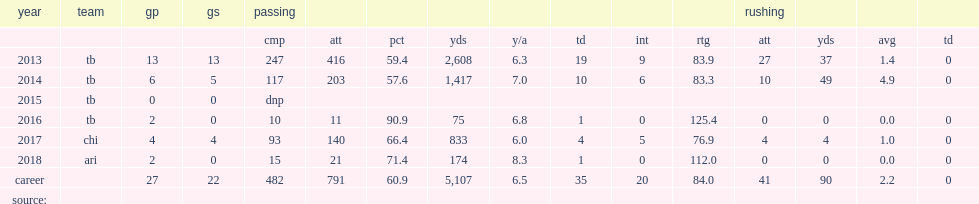In four games, how many passing yards did mike glennon finish with? 833.0. In four games, how many touchdowns did mike glennon finish with? 4.0. In four games, how many interceptions did mike glennon finish with? 5.0. Would you mind parsing the complete table? {'header': ['year', 'team', 'gp', 'gs', 'passing', '', '', '', '', '', '', '', 'rushing', '', '', ''], 'rows': [['', '', '', '', 'cmp', 'att', 'pct', 'yds', 'y/a', 'td', 'int', 'rtg', 'att', 'yds', 'avg', 'td'], ['2013', 'tb', '13', '13', '247', '416', '59.4', '2,608', '6.3', '19', '9', '83.9', '27', '37', '1.4', '0'], ['2014', 'tb', '6', '5', '117', '203', '57.6', '1,417', '7.0', '10', '6', '83.3', '10', '49', '4.9', '0'], ['2015', 'tb', '0', '0', 'dnp', '', '', '', '', '', '', '', '', '', '', ''], ['2016', 'tb', '2', '0', '10', '11', '90.9', '75', '6.8', '1', '0', '125.4', '0', '0', '0.0', '0'], ['2017', 'chi', '4', '4', '93', '140', '66.4', '833', '6.0', '4', '5', '76.9', '4', '4', '1.0', '0'], ['2018', 'ari', '2', '0', '15', '21', '71.4', '174', '8.3', '1', '0', '112.0', '0', '0', '0.0', '0'], ['career', '', '27', '22', '482', '791', '60.9', '5,107', '6.5', '35', '20', '84.0', '41', '90', '2.2', '0'], ['source:', '', '', '', '', '', '', '', '', '', '', '', '', '', '', '']]} 